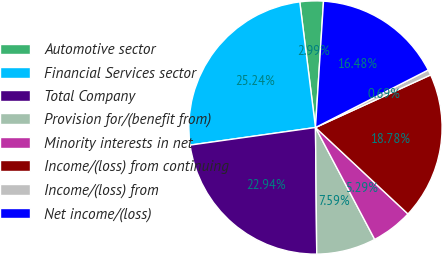<chart> <loc_0><loc_0><loc_500><loc_500><pie_chart><fcel>Automotive sector<fcel>Financial Services sector<fcel>Total Company<fcel>Provision for/(benefit from)<fcel>Minority interests in net<fcel>Income/(loss) from continuing<fcel>Income/(loss) from<fcel>Net income/(loss)<nl><fcel>2.99%<fcel>25.24%<fcel>22.94%<fcel>7.59%<fcel>5.29%<fcel>18.78%<fcel>0.69%<fcel>16.48%<nl></chart> 